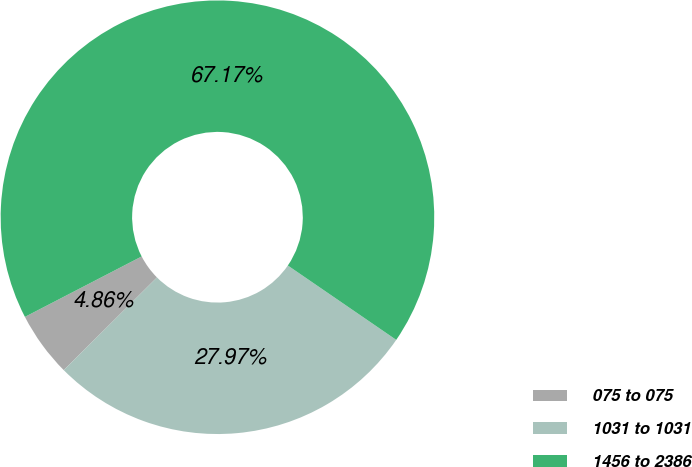Convert chart to OTSL. <chart><loc_0><loc_0><loc_500><loc_500><pie_chart><fcel>075 to 075<fcel>1031 to 1031<fcel>1456 to 2386<nl><fcel>4.86%<fcel>27.97%<fcel>67.17%<nl></chart> 